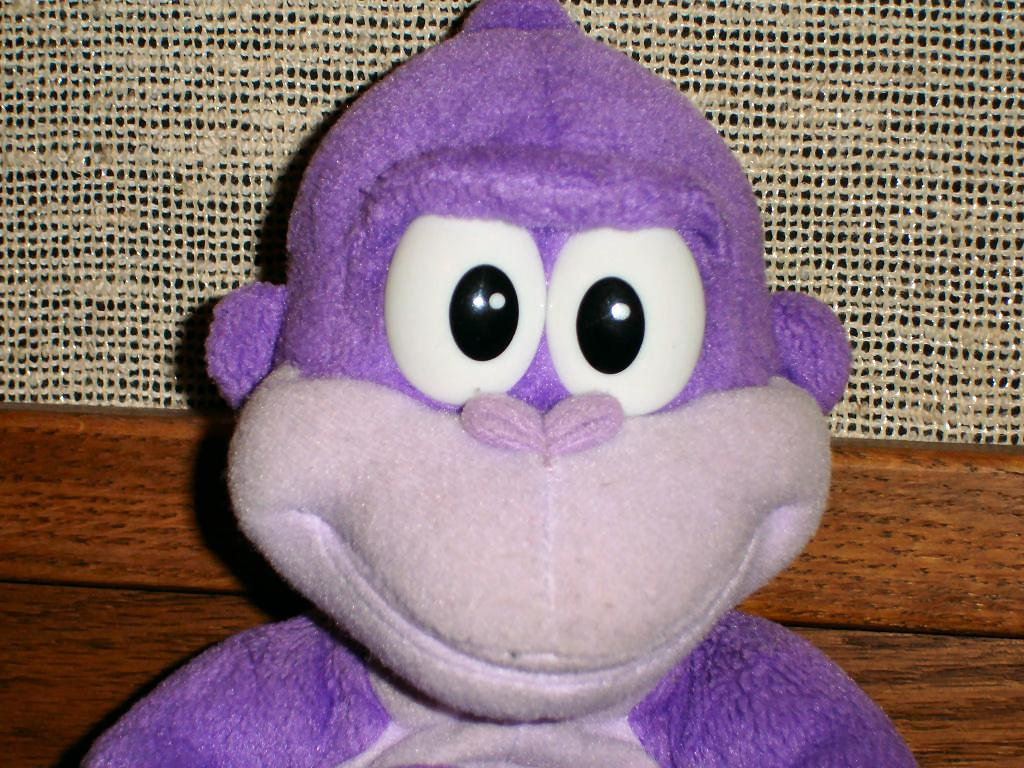What type of toy is present in the image? There is a soft toy in the image. What other object can be seen in the image? There is a wooden block in the image. What material is used for the cloth in the image? There is a jute cloth in the image. How does the field look like in the image? There is no field present in the image; it features a soft toy, wooden block, and jute cloth. What memory does the soft toy evoke in the image? The image does not depict any memories or emotions associated with the soft toy. 